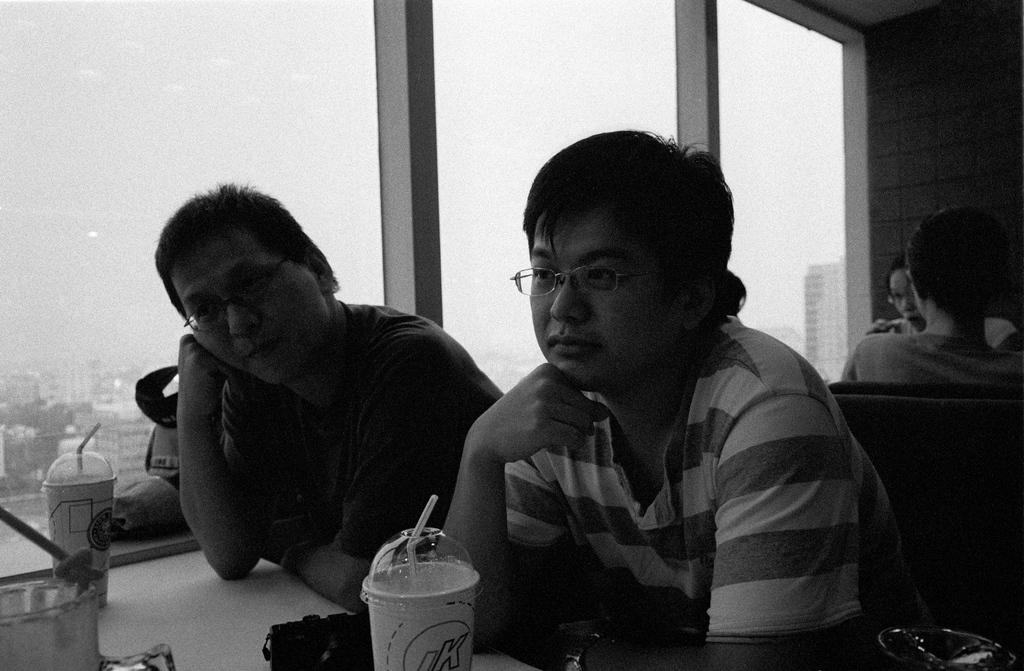How many people are present in the image? There are four people present in the image. What are the two persons in front of the table doing? The two persons sitting in front of the table are likely engaged in conversation or an activity together. What object is beside the two persons? There is a glass beside the two persons. Can you describe the arrangement of the people in the image? There are two persons sitting in front of the table, and two additional persons are standing behind them. What type of star is visible in the image? There is no star visible in the image; it is an indoor scene with people sitting at a table. What government policies are being discussed in the image? There is no indication in the image that the people are discussing government policies or any specific topic. 